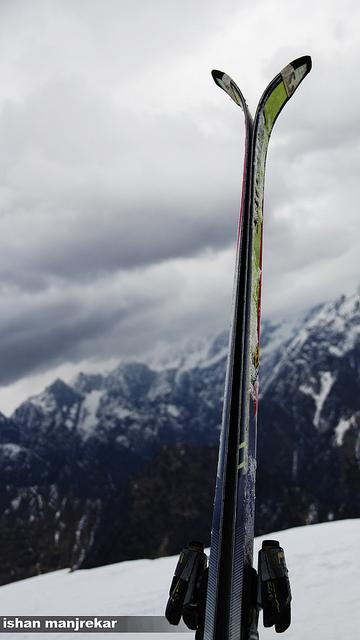What is this a photo of?
Short answer required. Skis. Is it a cloudy day out?
Be succinct. Yes. Is this a beach?
Keep it brief. No. 